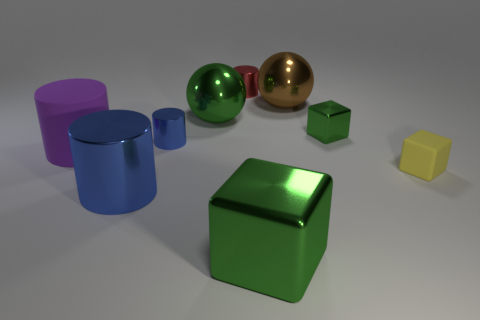Subtract all green spheres. How many spheres are left? 1 Subtract all tiny yellow matte cubes. How many cubes are left? 2 Subtract 0 cyan cubes. How many objects are left? 9 Subtract all blocks. How many objects are left? 6 Subtract 1 cubes. How many cubes are left? 2 Subtract all brown cubes. Subtract all blue spheres. How many cubes are left? 3 Subtract all purple cubes. How many green cylinders are left? 0 Subtract all blue things. Subtract all tiny metal cubes. How many objects are left? 6 Add 1 red metal cylinders. How many red metal cylinders are left? 2 Add 6 green spheres. How many green spheres exist? 7 